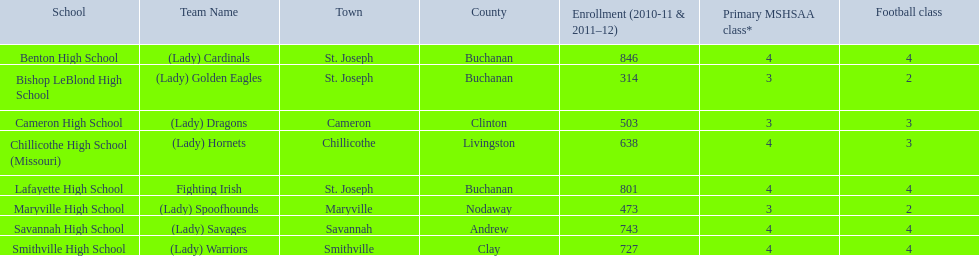How many of the educational institutions had a minimum of 500 students registered during the 2010-2011 and 2011-2012 period? 6. 